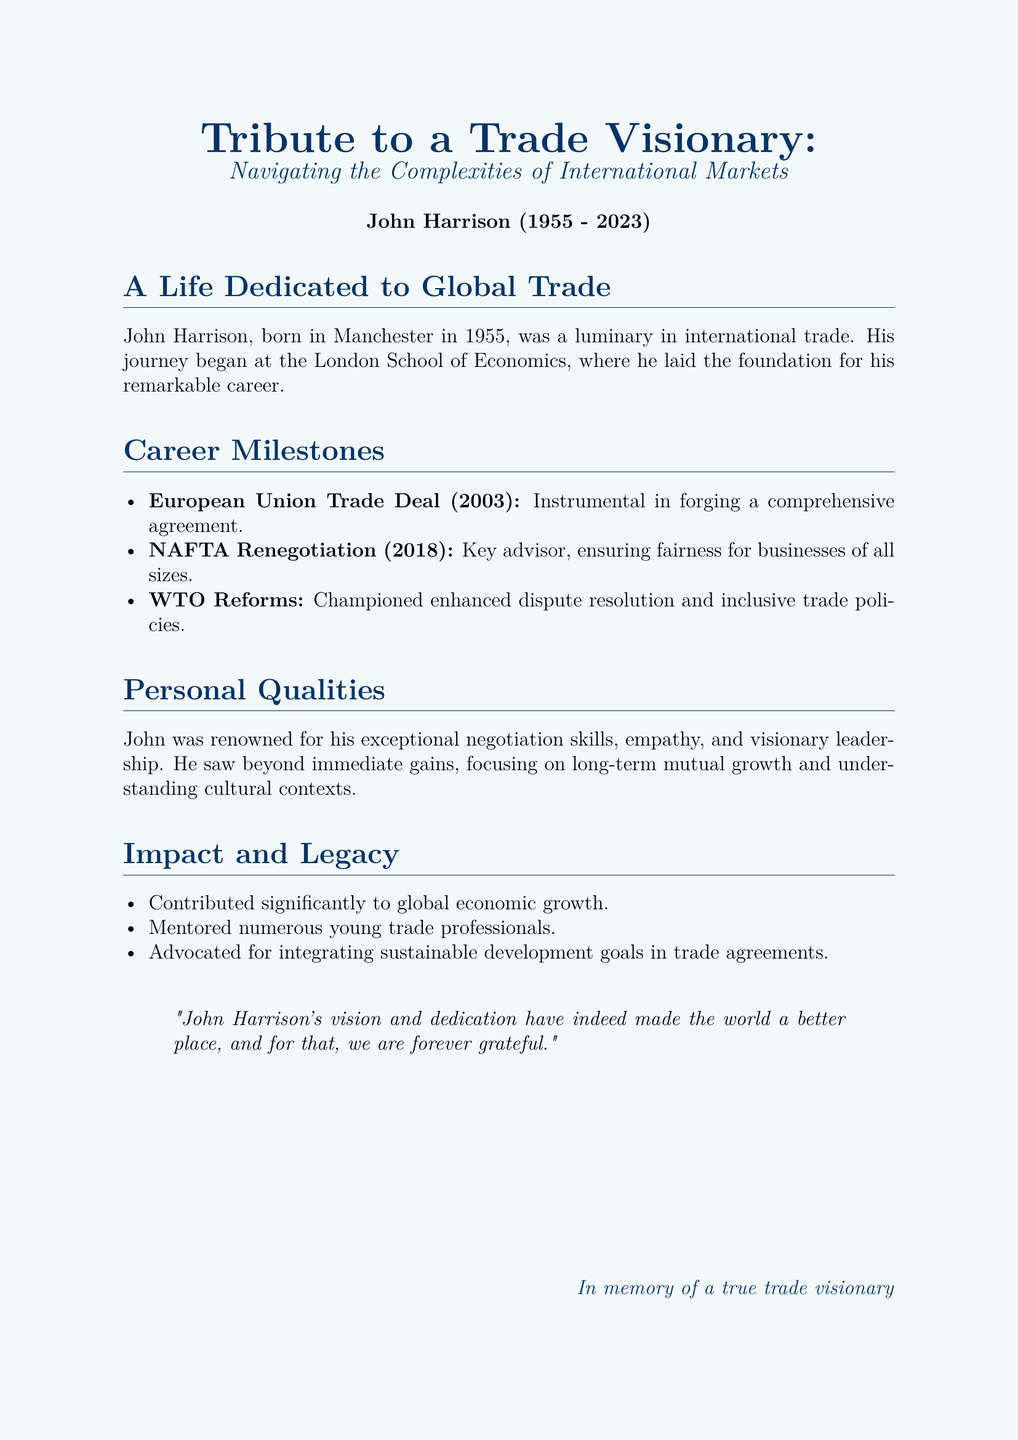What year was John Harrison born? The document states that John Harrison was born in Manchester in 1955.
Answer: 1955 What is the title of the document? The title of the document is "Tribute to a Trade Visionary: Navigating the Complexities of International Markets."
Answer: Tribute to a Trade Visionary: Navigating the Complexities of International Markets What major trade agreement did John work on in 2003? The document mentions that John was instrumental in forging a comprehensive agreement related to the European Union Trade Deal in 2003.
Answer: European Union Trade Deal Which program did John advise on in 2018? The text indicates that John was a key advisor in the NAFTA Renegotiation in 2018.
Answer: NAFTA Renegotiation What was a significant quality of John Harrison as noted in the document? The document highlights John's exceptional negotiation skills as one of his significant qualities.
Answer: Negotiation skills How did John contribute to the global economy? The document mentions that John made significant contributions to global economic growth.
Answer: Global economic growth What sustainable goal did John advocate for? The document states that John advocated for integrating sustainable development goals in trade agreements.
Answer: Sustainable development goals What institution did John attend? The document notes that John began his journey at the London School of Economics.
Answer: London School of Economics What is the year of John Harrison's passing? The document indicates that John Harrison passed away in 2023.
Answer: 2023 